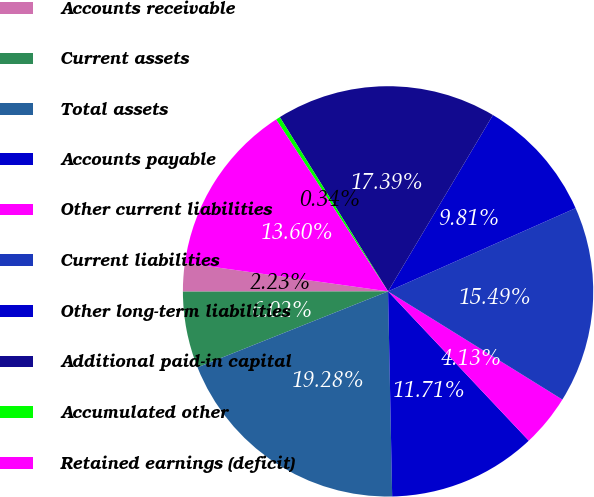Convert chart. <chart><loc_0><loc_0><loc_500><loc_500><pie_chart><fcel>Accounts receivable<fcel>Current assets<fcel>Total assets<fcel>Accounts payable<fcel>Other current liabilities<fcel>Current liabilities<fcel>Other long-term liabilities<fcel>Additional paid-in capital<fcel>Accumulated other<fcel>Retained earnings (deficit)<nl><fcel>2.23%<fcel>6.02%<fcel>19.28%<fcel>11.71%<fcel>4.13%<fcel>15.49%<fcel>9.81%<fcel>17.39%<fcel>0.34%<fcel>13.6%<nl></chart> 